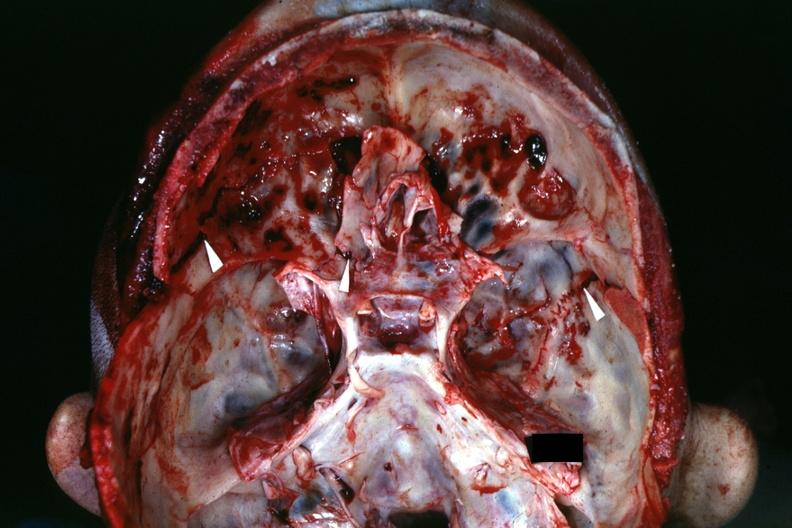does this image show view of base of skull with several well shown fractures?
Answer the question using a single word or phrase. Yes 